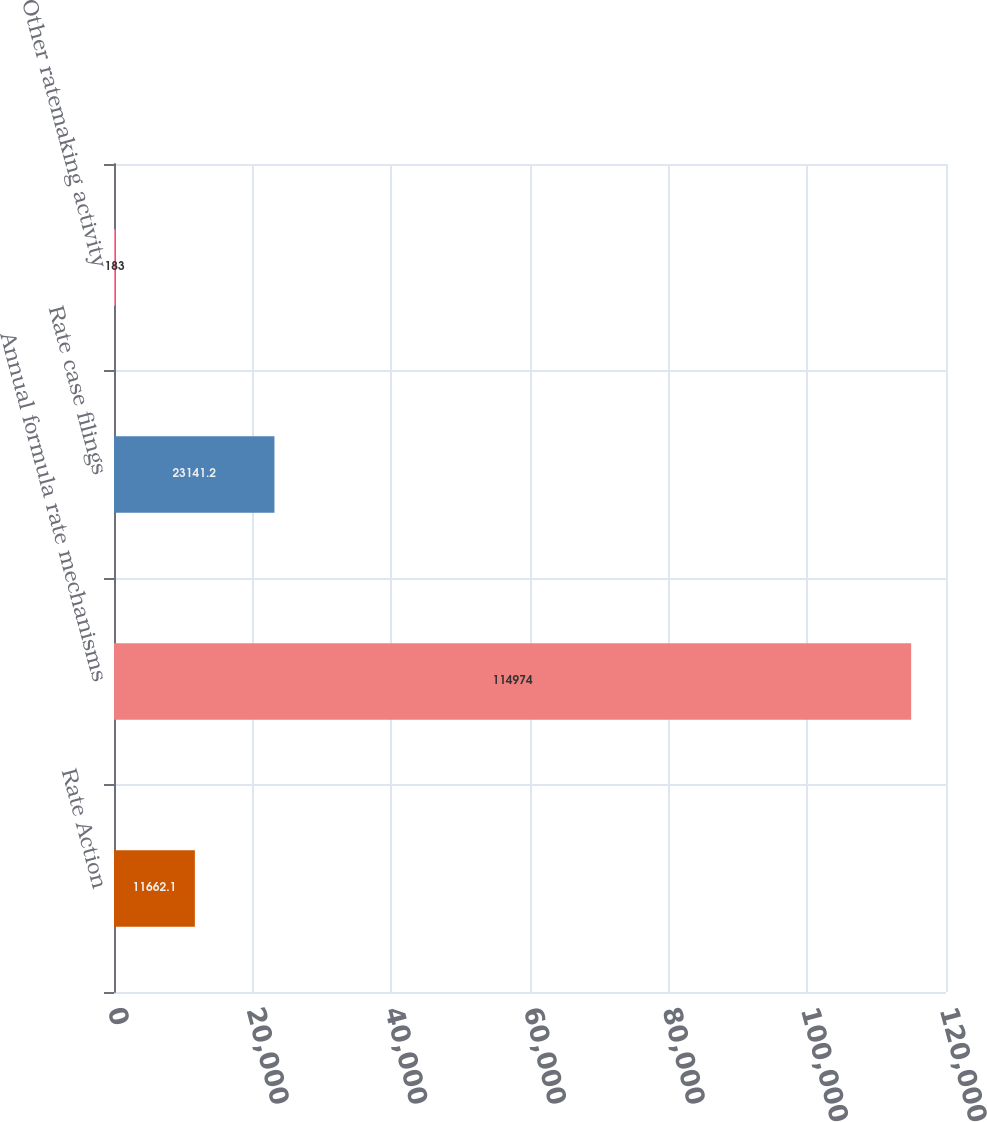Convert chart to OTSL. <chart><loc_0><loc_0><loc_500><loc_500><bar_chart><fcel>Rate Action<fcel>Annual formula rate mechanisms<fcel>Rate case filings<fcel>Other ratemaking activity<nl><fcel>11662.1<fcel>114974<fcel>23141.2<fcel>183<nl></chart> 